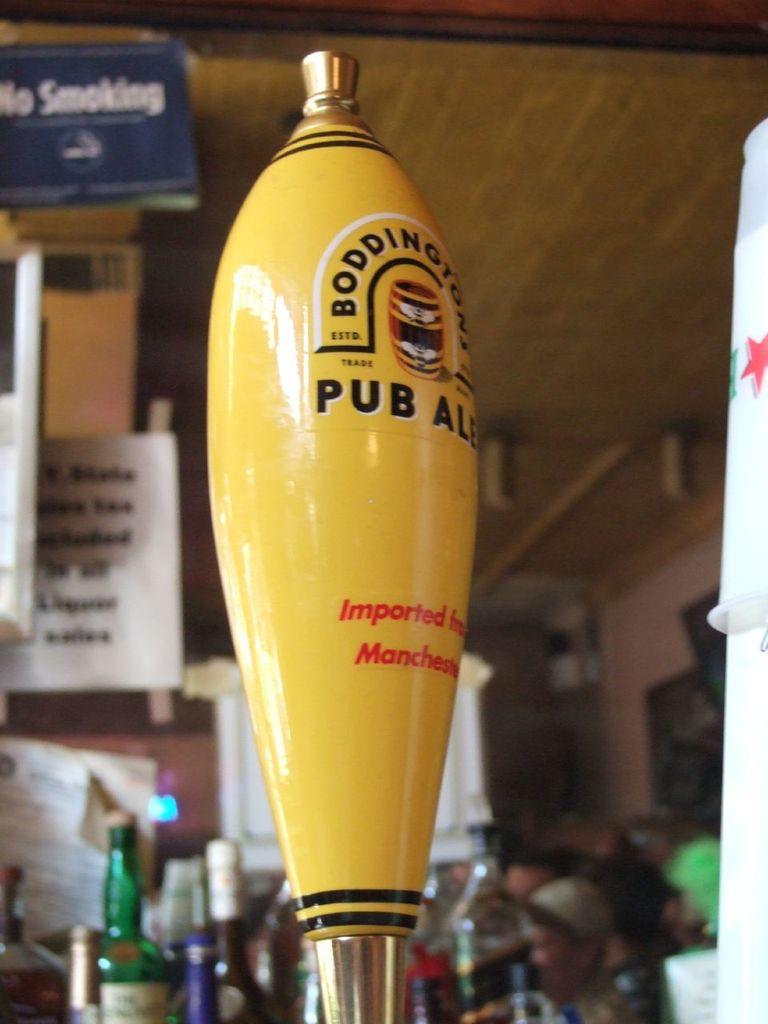Where is this ale imported from?
Offer a very short reply. Manchester. 